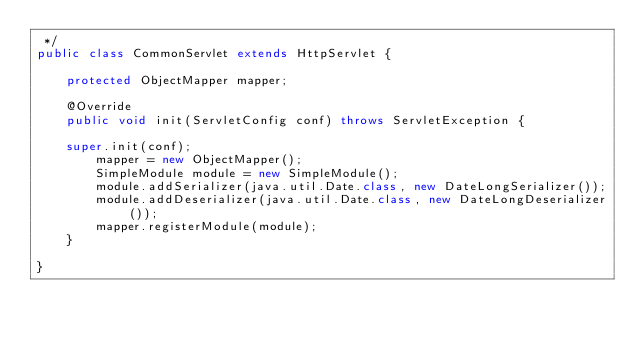Convert code to text. <code><loc_0><loc_0><loc_500><loc_500><_Java_> */
public class CommonServlet extends HttpServlet {

    protected ObjectMapper mapper;
    
    @Override
    public void init(ServletConfig conf) throws ServletException {

	super.init(conf);
        mapper = new ObjectMapper();
        SimpleModule module = new SimpleModule();
        module.addSerializer(java.util.Date.class, new DateLongSerializer());
        module.addDeserializer(java.util.Date.class, new DateLongDeserializer());
        mapper.registerModule(module);            
    }

}</code> 